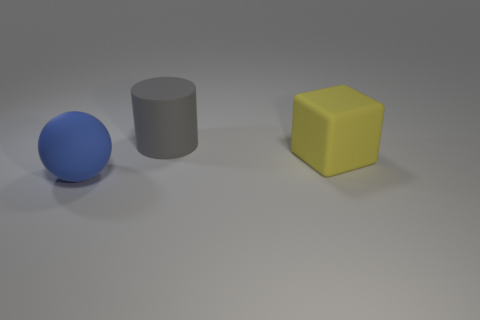Are there the same number of matte cylinders that are behind the big gray matte cylinder and yellow things to the left of the large yellow rubber thing?
Offer a terse response. Yes. There is a cube; is it the same size as the object that is in front of the yellow matte block?
Your response must be concise. Yes. There is a big object that is behind the yellow matte thing; are there any large rubber cylinders that are on the right side of it?
Offer a very short reply. No. Are there any other large gray things that have the same shape as the large gray thing?
Ensure brevity in your answer.  No. There is a big thing on the right side of the matte cylinder that is behind the large yellow rubber block; what number of yellow blocks are in front of it?
Offer a very short reply. 0. Do the rubber sphere and the matte object right of the gray thing have the same color?
Provide a succinct answer. No. What number of objects are either objects that are in front of the big yellow rubber cube or big rubber objects that are behind the blue rubber thing?
Offer a very short reply. 3. Are there more large things to the left of the yellow matte cube than big yellow objects to the left of the large matte ball?
Your answer should be compact. Yes. What material is the big object in front of the rubber thing on the right side of the cylinder left of the yellow rubber cube made of?
Provide a short and direct response. Rubber. There is a rubber object that is behind the yellow object; does it have the same shape as the rubber object that is to the left of the large gray cylinder?
Ensure brevity in your answer.  No. 